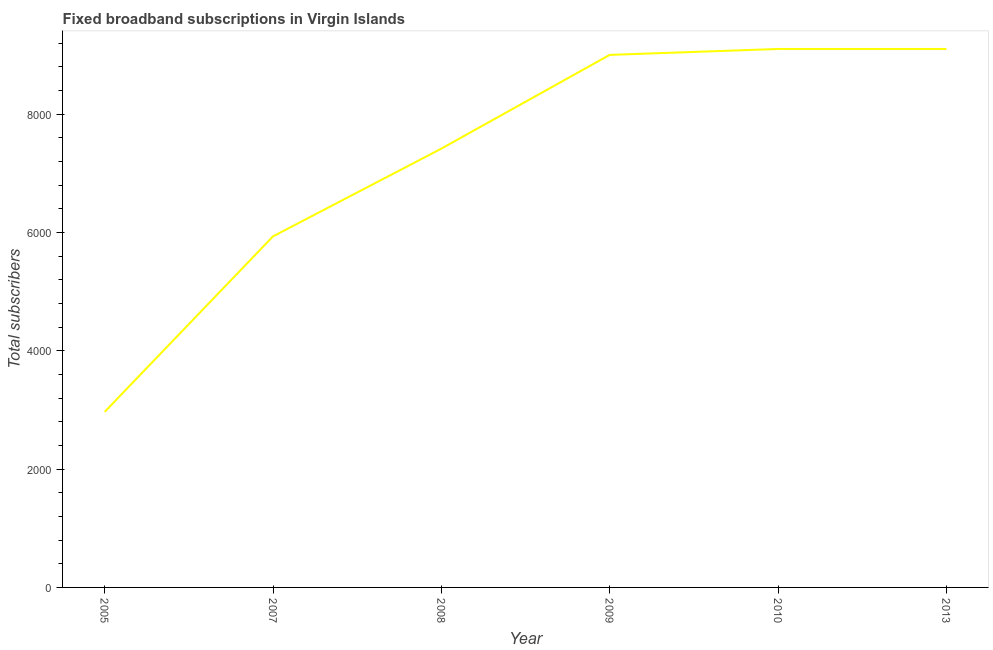What is the total number of fixed broadband subscriptions in 2005?
Ensure brevity in your answer.  2967. Across all years, what is the maximum total number of fixed broadband subscriptions?
Make the answer very short. 9100. Across all years, what is the minimum total number of fixed broadband subscriptions?
Make the answer very short. 2967. In which year was the total number of fixed broadband subscriptions maximum?
Provide a succinct answer. 2010. In which year was the total number of fixed broadband subscriptions minimum?
Keep it short and to the point. 2005. What is the sum of the total number of fixed broadband subscriptions?
Ensure brevity in your answer.  4.35e+04. What is the difference between the total number of fixed broadband subscriptions in 2005 and 2009?
Keep it short and to the point. -6033. What is the average total number of fixed broadband subscriptions per year?
Make the answer very short. 7252.67. What is the median total number of fixed broadband subscriptions?
Give a very brief answer. 8208. In how many years, is the total number of fixed broadband subscriptions greater than 4400 ?
Make the answer very short. 5. Do a majority of the years between 2005 and 2007 (inclusive) have total number of fixed broadband subscriptions greater than 800 ?
Give a very brief answer. Yes. What is the ratio of the total number of fixed broadband subscriptions in 2008 to that in 2009?
Provide a short and direct response. 0.82. Is the total number of fixed broadband subscriptions in 2005 less than that in 2009?
Your answer should be compact. Yes. What is the difference between the highest and the second highest total number of fixed broadband subscriptions?
Your answer should be very brief. 0. What is the difference between the highest and the lowest total number of fixed broadband subscriptions?
Give a very brief answer. 6133. In how many years, is the total number of fixed broadband subscriptions greater than the average total number of fixed broadband subscriptions taken over all years?
Offer a terse response. 4. Does the total number of fixed broadband subscriptions monotonically increase over the years?
Offer a very short reply. No. How many lines are there?
Give a very brief answer. 1. What is the difference between two consecutive major ticks on the Y-axis?
Give a very brief answer. 2000. Does the graph contain any zero values?
Keep it short and to the point. No. Does the graph contain grids?
Ensure brevity in your answer.  No. What is the title of the graph?
Provide a succinct answer. Fixed broadband subscriptions in Virgin Islands. What is the label or title of the Y-axis?
Offer a very short reply. Total subscribers. What is the Total subscribers of 2005?
Your answer should be compact. 2967. What is the Total subscribers in 2007?
Keep it short and to the point. 5933. What is the Total subscribers in 2008?
Your answer should be very brief. 7416. What is the Total subscribers of 2009?
Keep it short and to the point. 9000. What is the Total subscribers of 2010?
Provide a short and direct response. 9100. What is the Total subscribers of 2013?
Offer a terse response. 9100. What is the difference between the Total subscribers in 2005 and 2007?
Keep it short and to the point. -2966. What is the difference between the Total subscribers in 2005 and 2008?
Provide a short and direct response. -4449. What is the difference between the Total subscribers in 2005 and 2009?
Give a very brief answer. -6033. What is the difference between the Total subscribers in 2005 and 2010?
Provide a short and direct response. -6133. What is the difference between the Total subscribers in 2005 and 2013?
Provide a succinct answer. -6133. What is the difference between the Total subscribers in 2007 and 2008?
Offer a very short reply. -1483. What is the difference between the Total subscribers in 2007 and 2009?
Give a very brief answer. -3067. What is the difference between the Total subscribers in 2007 and 2010?
Keep it short and to the point. -3167. What is the difference between the Total subscribers in 2007 and 2013?
Keep it short and to the point. -3167. What is the difference between the Total subscribers in 2008 and 2009?
Provide a short and direct response. -1584. What is the difference between the Total subscribers in 2008 and 2010?
Offer a terse response. -1684. What is the difference between the Total subscribers in 2008 and 2013?
Provide a succinct answer. -1684. What is the difference between the Total subscribers in 2009 and 2010?
Ensure brevity in your answer.  -100. What is the difference between the Total subscribers in 2009 and 2013?
Make the answer very short. -100. What is the difference between the Total subscribers in 2010 and 2013?
Ensure brevity in your answer.  0. What is the ratio of the Total subscribers in 2005 to that in 2007?
Offer a terse response. 0.5. What is the ratio of the Total subscribers in 2005 to that in 2008?
Your response must be concise. 0.4. What is the ratio of the Total subscribers in 2005 to that in 2009?
Ensure brevity in your answer.  0.33. What is the ratio of the Total subscribers in 2005 to that in 2010?
Provide a succinct answer. 0.33. What is the ratio of the Total subscribers in 2005 to that in 2013?
Keep it short and to the point. 0.33. What is the ratio of the Total subscribers in 2007 to that in 2008?
Your answer should be compact. 0.8. What is the ratio of the Total subscribers in 2007 to that in 2009?
Your answer should be compact. 0.66. What is the ratio of the Total subscribers in 2007 to that in 2010?
Offer a very short reply. 0.65. What is the ratio of the Total subscribers in 2007 to that in 2013?
Your answer should be compact. 0.65. What is the ratio of the Total subscribers in 2008 to that in 2009?
Keep it short and to the point. 0.82. What is the ratio of the Total subscribers in 2008 to that in 2010?
Provide a succinct answer. 0.81. What is the ratio of the Total subscribers in 2008 to that in 2013?
Provide a short and direct response. 0.81. What is the ratio of the Total subscribers in 2009 to that in 2010?
Your answer should be compact. 0.99. 